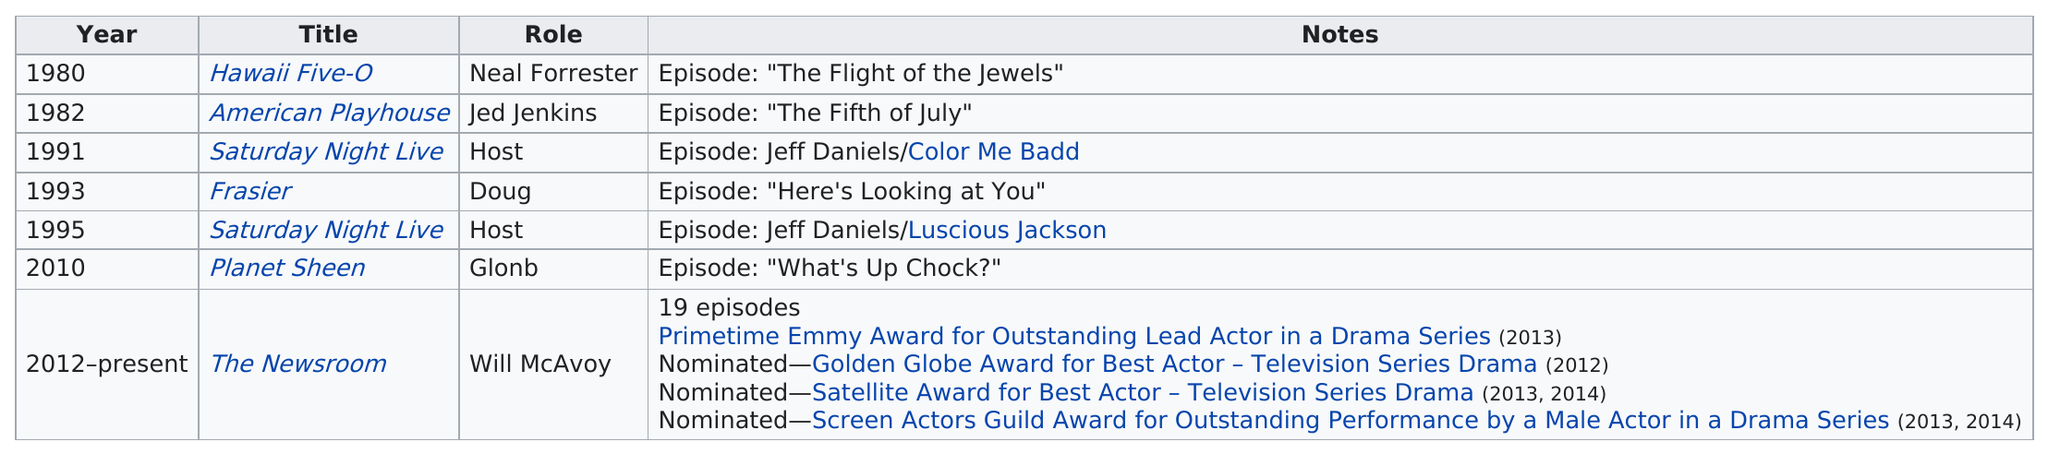Identify some key points in this picture. Daniels was in The Newsroom after Planet Sheen. There are two episodes that include the title "Jeff Daniels". Saturday Night Live" is a list of titles that include "host" as the role. Jeff Daniels has starred in several television shows, and he has appeared in the most number of episodes for The Newsroom. Jeff Daniels was nominated for both an Emmy Award and a Golden Globe Award for his performance in the television show "The Newsroom. 